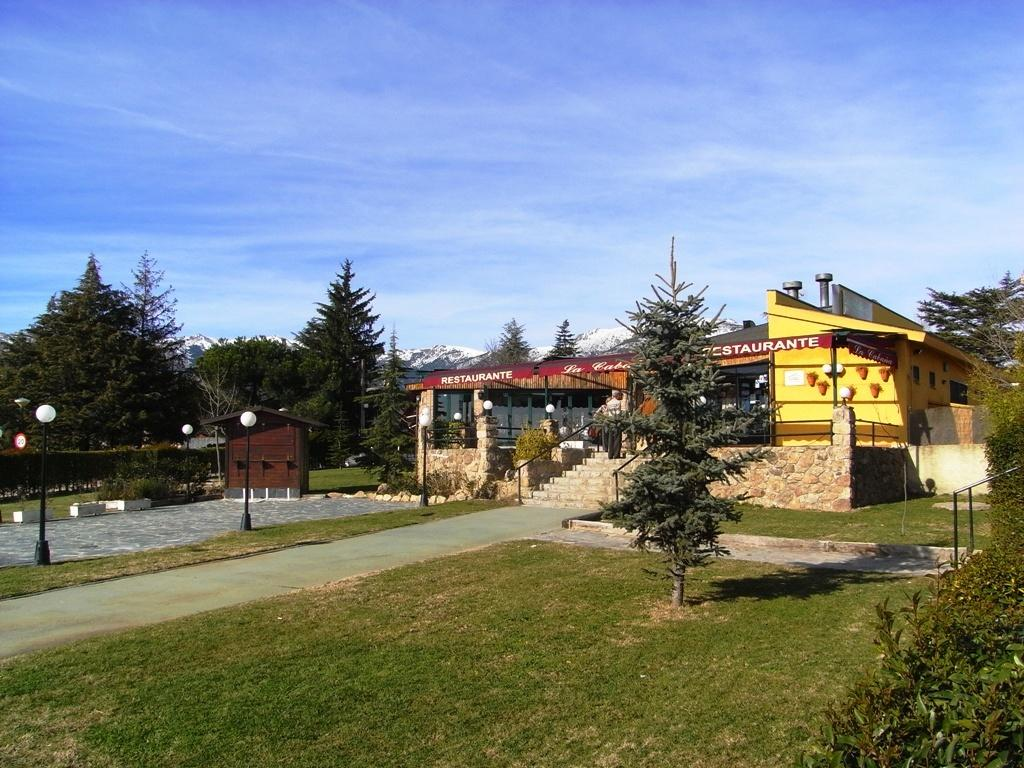What type of vegetation can be seen in the image? There is grass in the image. What feature is present for walking or traversing the area? There is a path in the image. Where can people find shade in the image? There is a shaded area in the image. What type of natural elements are present in the image? There are trees in the image. What structures are present for supporting or holding something? There are poles in the image. What illuminates the area in the image? There are lights in the image. What type of man-made structure is present in the image? There is a building in the image. What type of decorative or informative elements are present in the image? There are banners in the image. What architectural feature is present for ascending or descending the area? There are steps in the image. What type of enclosing structures are present in the image? There are walls in the image. What can be seen in the background of the image? The sky is visible in the background of the image, with clouds present. How does the wool in the image contribute to the overall aesthetic? There is no wool present in the image. What is the comparison between the size of the cent and the building in the image? There is no cent present in the image, so a comparison cannot be made. 